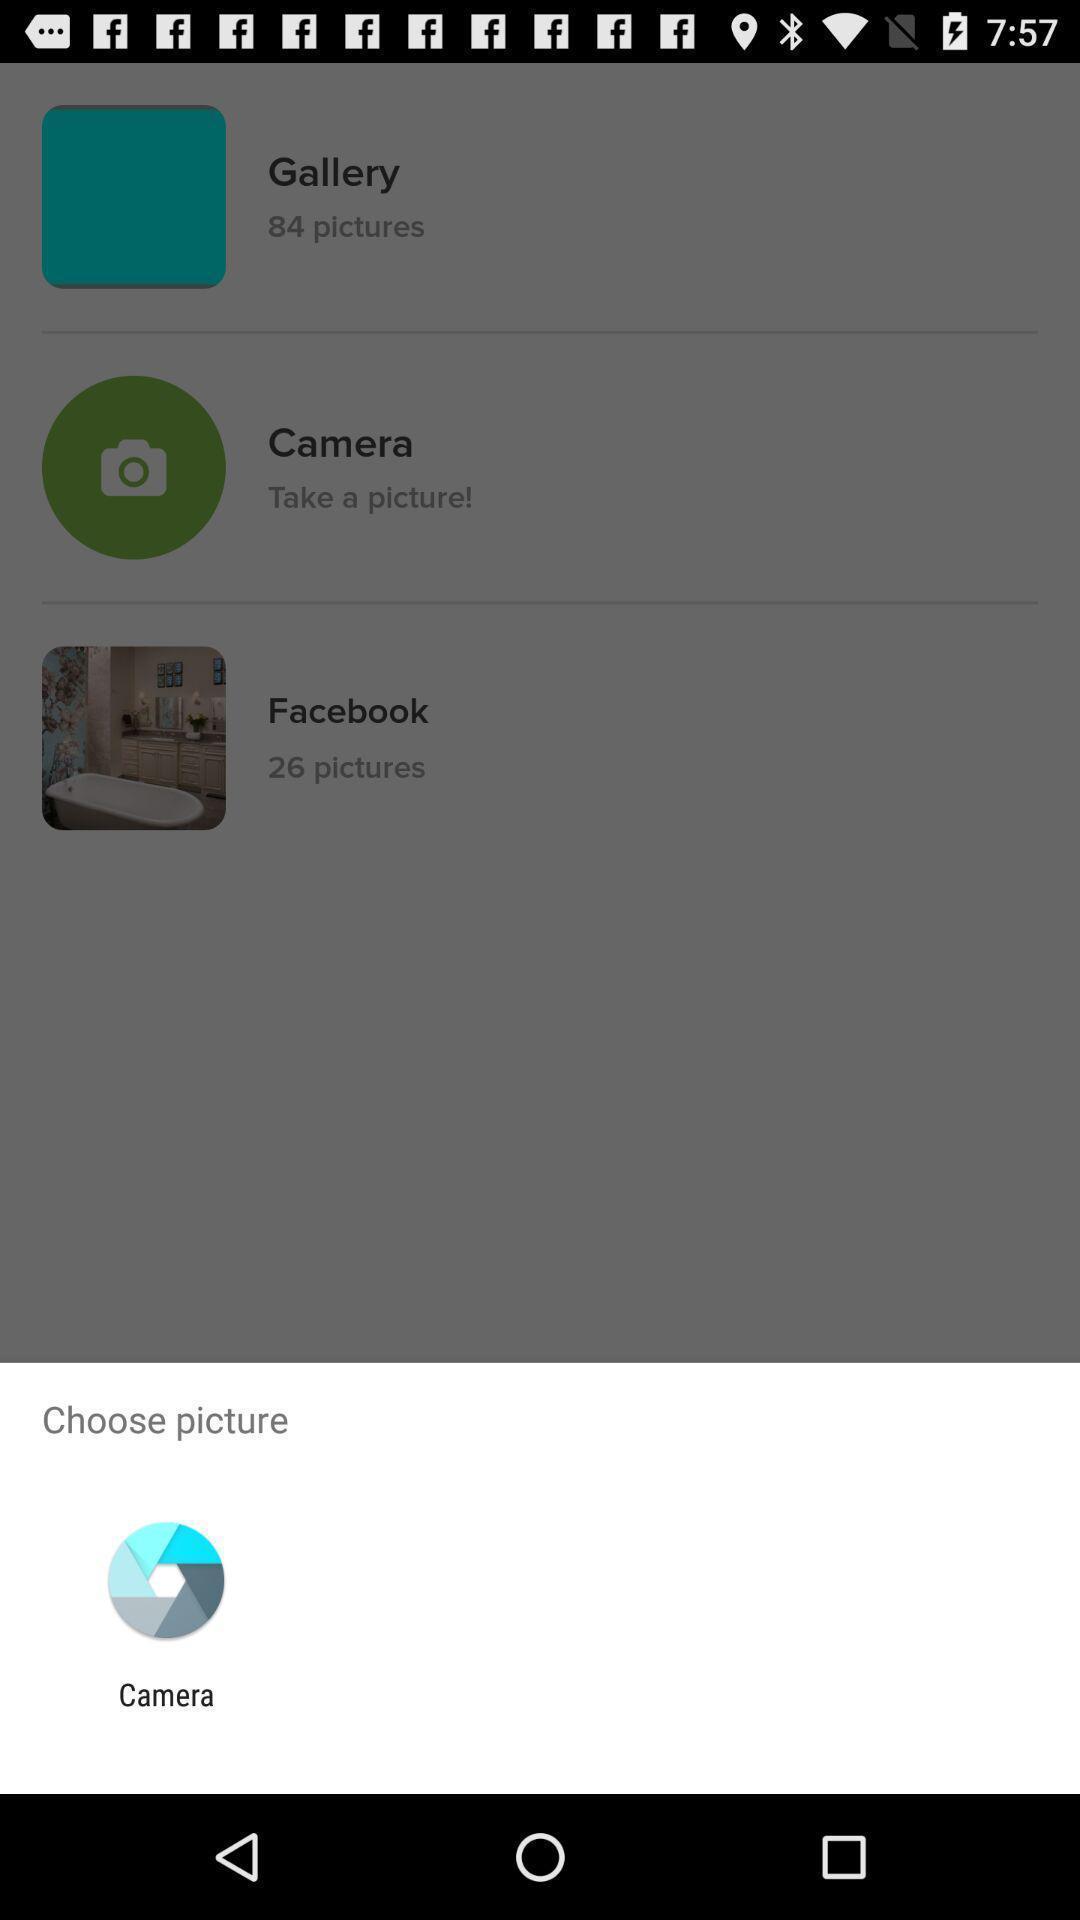Describe this image in words. Pop-up shows to choose a picture with app. 